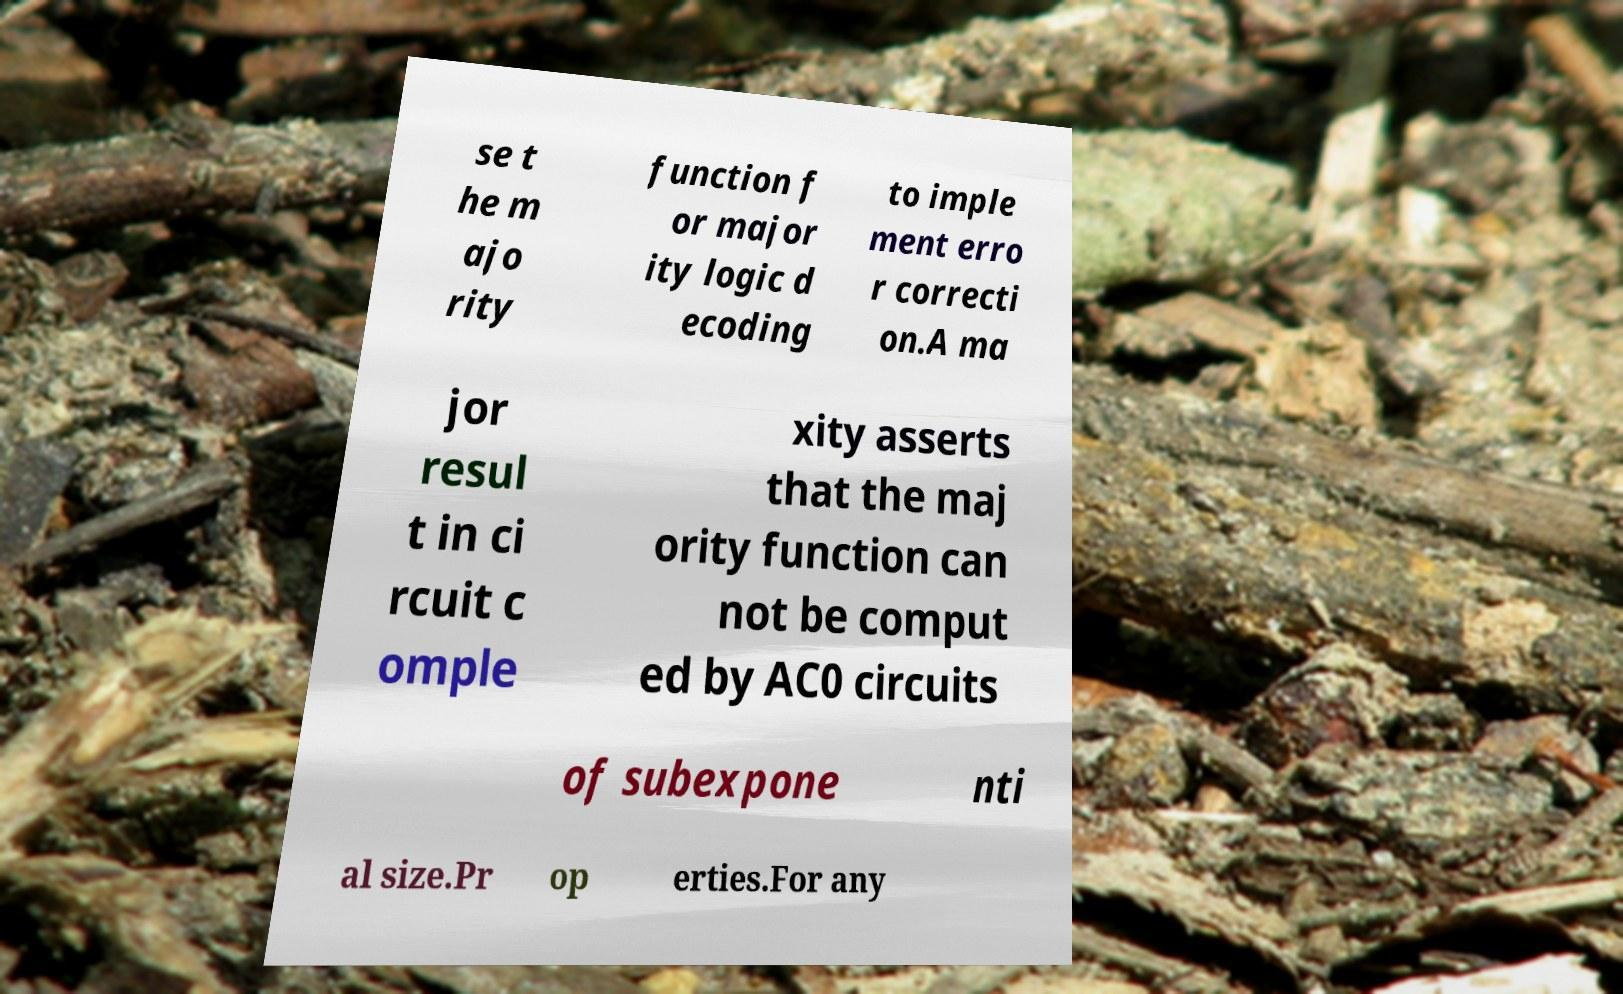Could you extract and type out the text from this image? se t he m ajo rity function f or major ity logic d ecoding to imple ment erro r correcti on.A ma jor resul t in ci rcuit c omple xity asserts that the maj ority function can not be comput ed by AC0 circuits of subexpone nti al size.Pr op erties.For any 